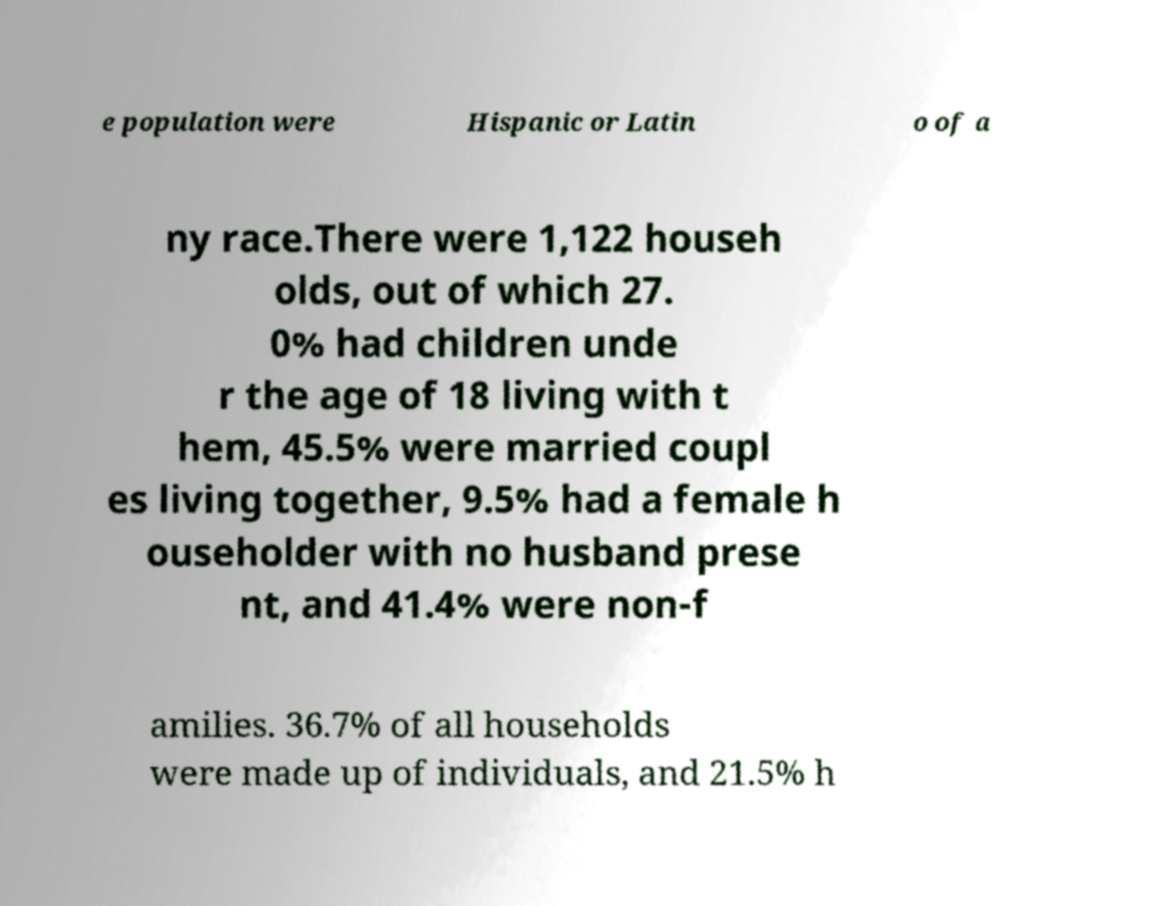Could you extract and type out the text from this image? e population were Hispanic or Latin o of a ny race.There were 1,122 househ olds, out of which 27. 0% had children unde r the age of 18 living with t hem, 45.5% were married coupl es living together, 9.5% had a female h ouseholder with no husband prese nt, and 41.4% were non-f amilies. 36.7% of all households were made up of individuals, and 21.5% h 